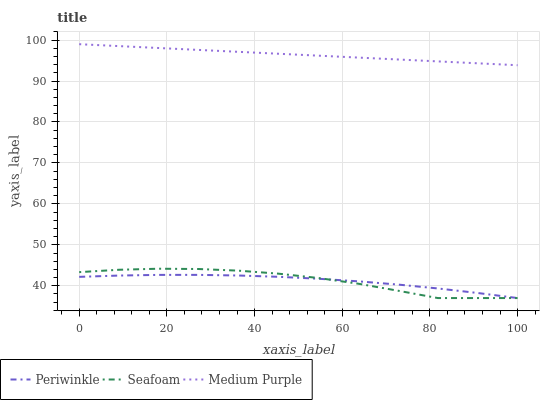Does Periwinkle have the minimum area under the curve?
Answer yes or no. Yes. Does Medium Purple have the maximum area under the curve?
Answer yes or no. Yes. Does Seafoam have the minimum area under the curve?
Answer yes or no. No. Does Seafoam have the maximum area under the curve?
Answer yes or no. No. Is Medium Purple the smoothest?
Answer yes or no. Yes. Is Seafoam the roughest?
Answer yes or no. Yes. Is Periwinkle the smoothest?
Answer yes or no. No. Is Periwinkle the roughest?
Answer yes or no. No. Does Periwinkle have the lowest value?
Answer yes or no. Yes. Does Medium Purple have the highest value?
Answer yes or no. Yes. Does Seafoam have the highest value?
Answer yes or no. No. Is Periwinkle less than Medium Purple?
Answer yes or no. Yes. Is Medium Purple greater than Periwinkle?
Answer yes or no. Yes. Does Seafoam intersect Periwinkle?
Answer yes or no. Yes. Is Seafoam less than Periwinkle?
Answer yes or no. No. Is Seafoam greater than Periwinkle?
Answer yes or no. No. Does Periwinkle intersect Medium Purple?
Answer yes or no. No. 